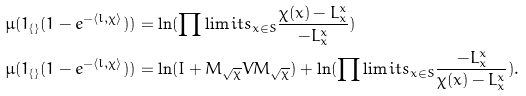Convert formula to latex. <formula><loc_0><loc_0><loc_500><loc_500>& \mu ( 1 _ { \{ \} } ( 1 - e ^ { - \langle l , \chi \rangle } ) ) = \ln ( \prod \lim i t s _ { x \in S } \frac { \chi ( x ) - L ^ { x } _ { x } } { - L ^ { x } _ { x } } ) \\ & \mu ( 1 _ { \{ \} } ( 1 - e ^ { - \langle l , \chi \rangle } ) ) = \ln ( I + M _ { \sqrt { \chi } } V M _ { \sqrt { \chi } } ) + \ln ( \prod \lim i t s _ { x \in S } \frac { - L ^ { x } _ { x } } { \chi ( x ) - L ^ { x } _ { x } } ) .</formula> 